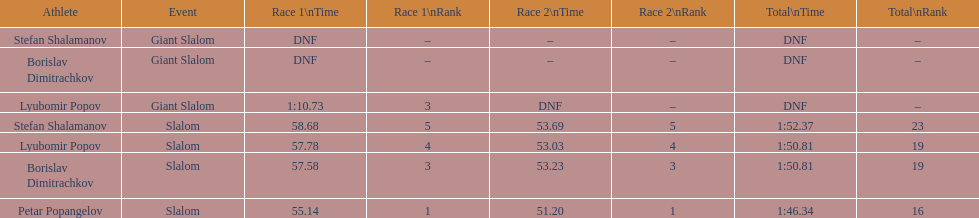Which athlete had a race time above 1:00? Lyubomir Popov. 